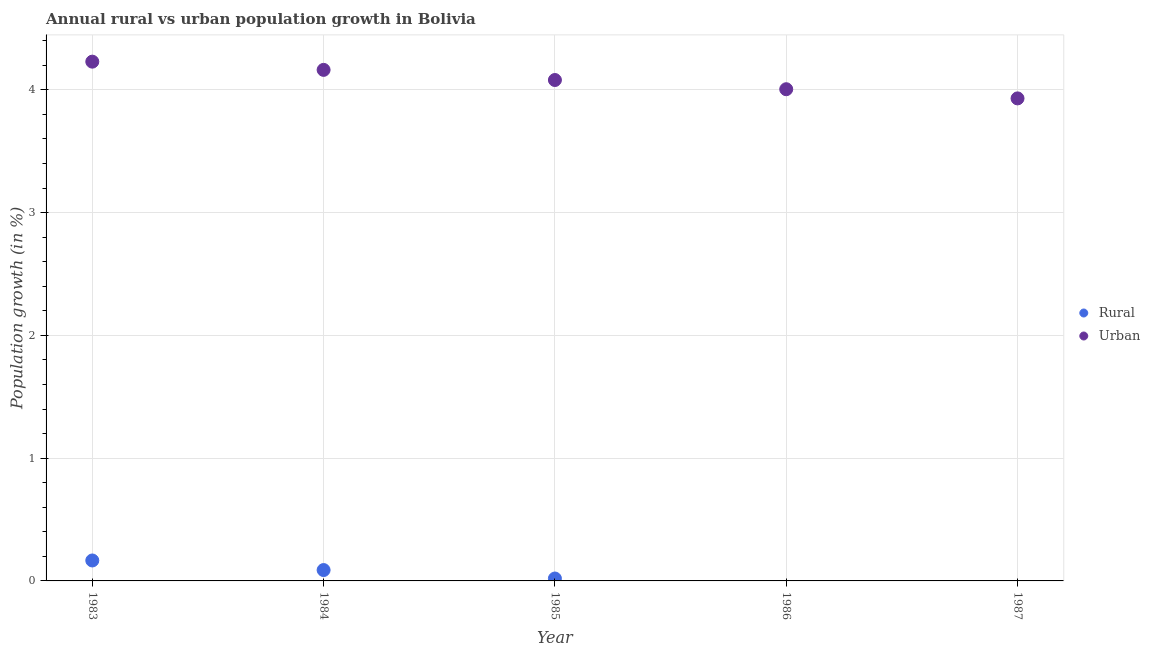What is the urban population growth in 1984?
Ensure brevity in your answer.  4.16. Across all years, what is the maximum rural population growth?
Offer a terse response. 0.17. Across all years, what is the minimum rural population growth?
Give a very brief answer. 0. What is the total urban population growth in the graph?
Provide a short and direct response. 20.41. What is the difference between the rural population growth in 1984 and that in 1985?
Your answer should be compact. 0.07. What is the difference between the urban population growth in 1986 and the rural population growth in 1984?
Offer a very short reply. 3.92. What is the average rural population growth per year?
Offer a very short reply. 0.05. In the year 1984, what is the difference between the rural population growth and urban population growth?
Offer a terse response. -4.07. In how many years, is the urban population growth greater than 0.6000000000000001 %?
Give a very brief answer. 5. What is the ratio of the rural population growth in 1983 to that in 1985?
Offer a very short reply. 8.49. Is the rural population growth in 1983 less than that in 1984?
Your answer should be very brief. No. What is the difference between the highest and the second highest rural population growth?
Provide a succinct answer. 0.08. What is the difference between the highest and the lowest urban population growth?
Your answer should be very brief. 0.3. Is the sum of the rural population growth in 1983 and 1985 greater than the maximum urban population growth across all years?
Your answer should be very brief. No. Is the urban population growth strictly greater than the rural population growth over the years?
Provide a succinct answer. Yes. How many years are there in the graph?
Provide a succinct answer. 5. What is the difference between two consecutive major ticks on the Y-axis?
Offer a very short reply. 1. How many legend labels are there?
Provide a succinct answer. 2. How are the legend labels stacked?
Ensure brevity in your answer.  Vertical. What is the title of the graph?
Ensure brevity in your answer.  Annual rural vs urban population growth in Bolivia. What is the label or title of the Y-axis?
Your answer should be very brief. Population growth (in %). What is the Population growth (in %) in Rural in 1983?
Provide a succinct answer. 0.17. What is the Population growth (in %) of Urban  in 1983?
Make the answer very short. 4.23. What is the Population growth (in %) of Rural in 1984?
Your answer should be compact. 0.09. What is the Population growth (in %) in Urban  in 1984?
Your answer should be very brief. 4.16. What is the Population growth (in %) of Rural in 1985?
Offer a terse response. 0.02. What is the Population growth (in %) of Urban  in 1985?
Your answer should be compact. 4.08. What is the Population growth (in %) of Rural in 1986?
Give a very brief answer. 0. What is the Population growth (in %) in Urban  in 1986?
Provide a succinct answer. 4. What is the Population growth (in %) of Urban  in 1987?
Your response must be concise. 3.93. Across all years, what is the maximum Population growth (in %) in Rural?
Keep it short and to the point. 0.17. Across all years, what is the maximum Population growth (in %) of Urban ?
Provide a succinct answer. 4.23. Across all years, what is the minimum Population growth (in %) of Rural?
Offer a terse response. 0. Across all years, what is the minimum Population growth (in %) of Urban ?
Your answer should be compact. 3.93. What is the total Population growth (in %) of Rural in the graph?
Provide a succinct answer. 0.27. What is the total Population growth (in %) in Urban  in the graph?
Your answer should be compact. 20.41. What is the difference between the Population growth (in %) of Rural in 1983 and that in 1984?
Your response must be concise. 0.08. What is the difference between the Population growth (in %) in Urban  in 1983 and that in 1984?
Provide a succinct answer. 0.07. What is the difference between the Population growth (in %) in Rural in 1983 and that in 1985?
Your response must be concise. 0.15. What is the difference between the Population growth (in %) in Urban  in 1983 and that in 1985?
Make the answer very short. 0.15. What is the difference between the Population growth (in %) of Urban  in 1983 and that in 1986?
Make the answer very short. 0.22. What is the difference between the Population growth (in %) of Urban  in 1983 and that in 1987?
Provide a short and direct response. 0.3. What is the difference between the Population growth (in %) in Rural in 1984 and that in 1985?
Keep it short and to the point. 0.07. What is the difference between the Population growth (in %) in Urban  in 1984 and that in 1985?
Make the answer very short. 0.08. What is the difference between the Population growth (in %) of Urban  in 1984 and that in 1986?
Make the answer very short. 0.16. What is the difference between the Population growth (in %) in Urban  in 1984 and that in 1987?
Ensure brevity in your answer.  0.23. What is the difference between the Population growth (in %) of Urban  in 1985 and that in 1986?
Offer a terse response. 0.07. What is the difference between the Population growth (in %) in Urban  in 1985 and that in 1987?
Your answer should be very brief. 0.15. What is the difference between the Population growth (in %) of Urban  in 1986 and that in 1987?
Provide a short and direct response. 0.07. What is the difference between the Population growth (in %) in Rural in 1983 and the Population growth (in %) in Urban  in 1984?
Ensure brevity in your answer.  -4. What is the difference between the Population growth (in %) in Rural in 1983 and the Population growth (in %) in Urban  in 1985?
Keep it short and to the point. -3.91. What is the difference between the Population growth (in %) of Rural in 1983 and the Population growth (in %) of Urban  in 1986?
Keep it short and to the point. -3.84. What is the difference between the Population growth (in %) in Rural in 1983 and the Population growth (in %) in Urban  in 1987?
Provide a succinct answer. -3.76. What is the difference between the Population growth (in %) of Rural in 1984 and the Population growth (in %) of Urban  in 1985?
Offer a very short reply. -3.99. What is the difference between the Population growth (in %) in Rural in 1984 and the Population growth (in %) in Urban  in 1986?
Offer a very short reply. -3.92. What is the difference between the Population growth (in %) of Rural in 1984 and the Population growth (in %) of Urban  in 1987?
Your answer should be compact. -3.84. What is the difference between the Population growth (in %) in Rural in 1985 and the Population growth (in %) in Urban  in 1986?
Your response must be concise. -3.99. What is the difference between the Population growth (in %) in Rural in 1985 and the Population growth (in %) in Urban  in 1987?
Ensure brevity in your answer.  -3.91. What is the average Population growth (in %) in Rural per year?
Your answer should be very brief. 0.05. What is the average Population growth (in %) of Urban  per year?
Your response must be concise. 4.08. In the year 1983, what is the difference between the Population growth (in %) of Rural and Population growth (in %) of Urban ?
Offer a terse response. -4.06. In the year 1984, what is the difference between the Population growth (in %) of Rural and Population growth (in %) of Urban ?
Ensure brevity in your answer.  -4.07. In the year 1985, what is the difference between the Population growth (in %) in Rural and Population growth (in %) in Urban ?
Provide a short and direct response. -4.06. What is the ratio of the Population growth (in %) in Rural in 1983 to that in 1984?
Ensure brevity in your answer.  1.88. What is the ratio of the Population growth (in %) in Urban  in 1983 to that in 1984?
Offer a terse response. 1.02. What is the ratio of the Population growth (in %) in Rural in 1983 to that in 1985?
Ensure brevity in your answer.  8.49. What is the ratio of the Population growth (in %) of Urban  in 1983 to that in 1985?
Provide a short and direct response. 1.04. What is the ratio of the Population growth (in %) of Urban  in 1983 to that in 1986?
Ensure brevity in your answer.  1.06. What is the ratio of the Population growth (in %) in Urban  in 1983 to that in 1987?
Offer a very short reply. 1.08. What is the ratio of the Population growth (in %) of Rural in 1984 to that in 1985?
Give a very brief answer. 4.51. What is the ratio of the Population growth (in %) of Urban  in 1984 to that in 1985?
Provide a succinct answer. 1.02. What is the ratio of the Population growth (in %) of Urban  in 1984 to that in 1986?
Give a very brief answer. 1.04. What is the ratio of the Population growth (in %) of Urban  in 1984 to that in 1987?
Your answer should be compact. 1.06. What is the ratio of the Population growth (in %) of Urban  in 1985 to that in 1986?
Provide a short and direct response. 1.02. What is the ratio of the Population growth (in %) in Urban  in 1985 to that in 1987?
Keep it short and to the point. 1.04. What is the ratio of the Population growth (in %) of Urban  in 1986 to that in 1987?
Ensure brevity in your answer.  1.02. What is the difference between the highest and the second highest Population growth (in %) in Rural?
Your answer should be compact. 0.08. What is the difference between the highest and the second highest Population growth (in %) of Urban ?
Your answer should be compact. 0.07. What is the difference between the highest and the lowest Population growth (in %) of Rural?
Offer a terse response. 0.17. What is the difference between the highest and the lowest Population growth (in %) of Urban ?
Offer a terse response. 0.3. 